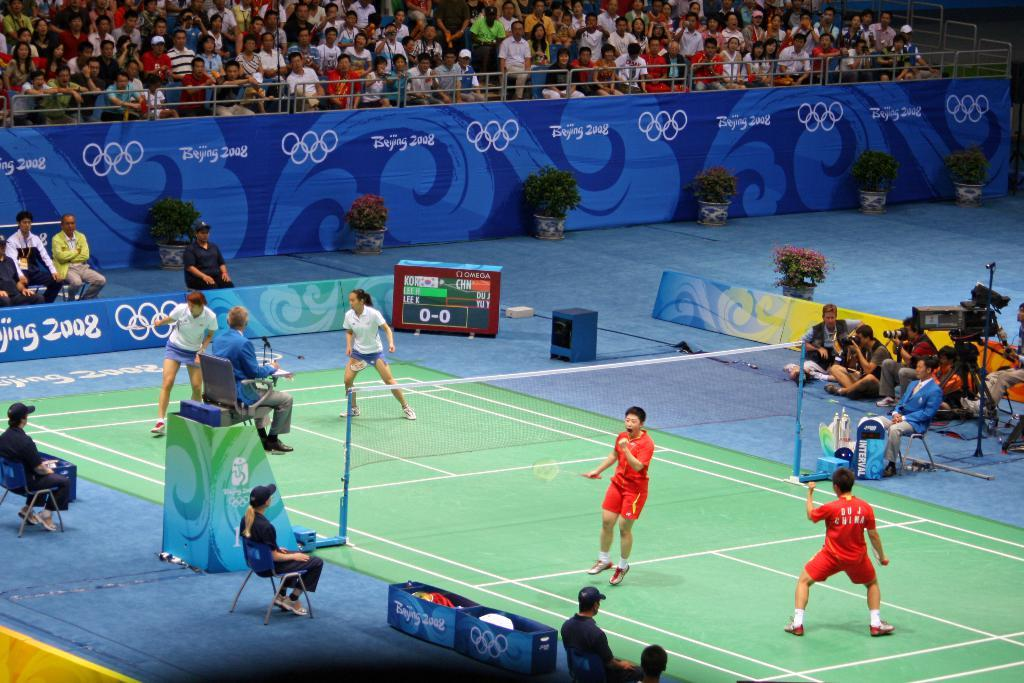<image>
Render a clear and concise summary of the photo. A group of people playing tennis in the olympics in 2008. 